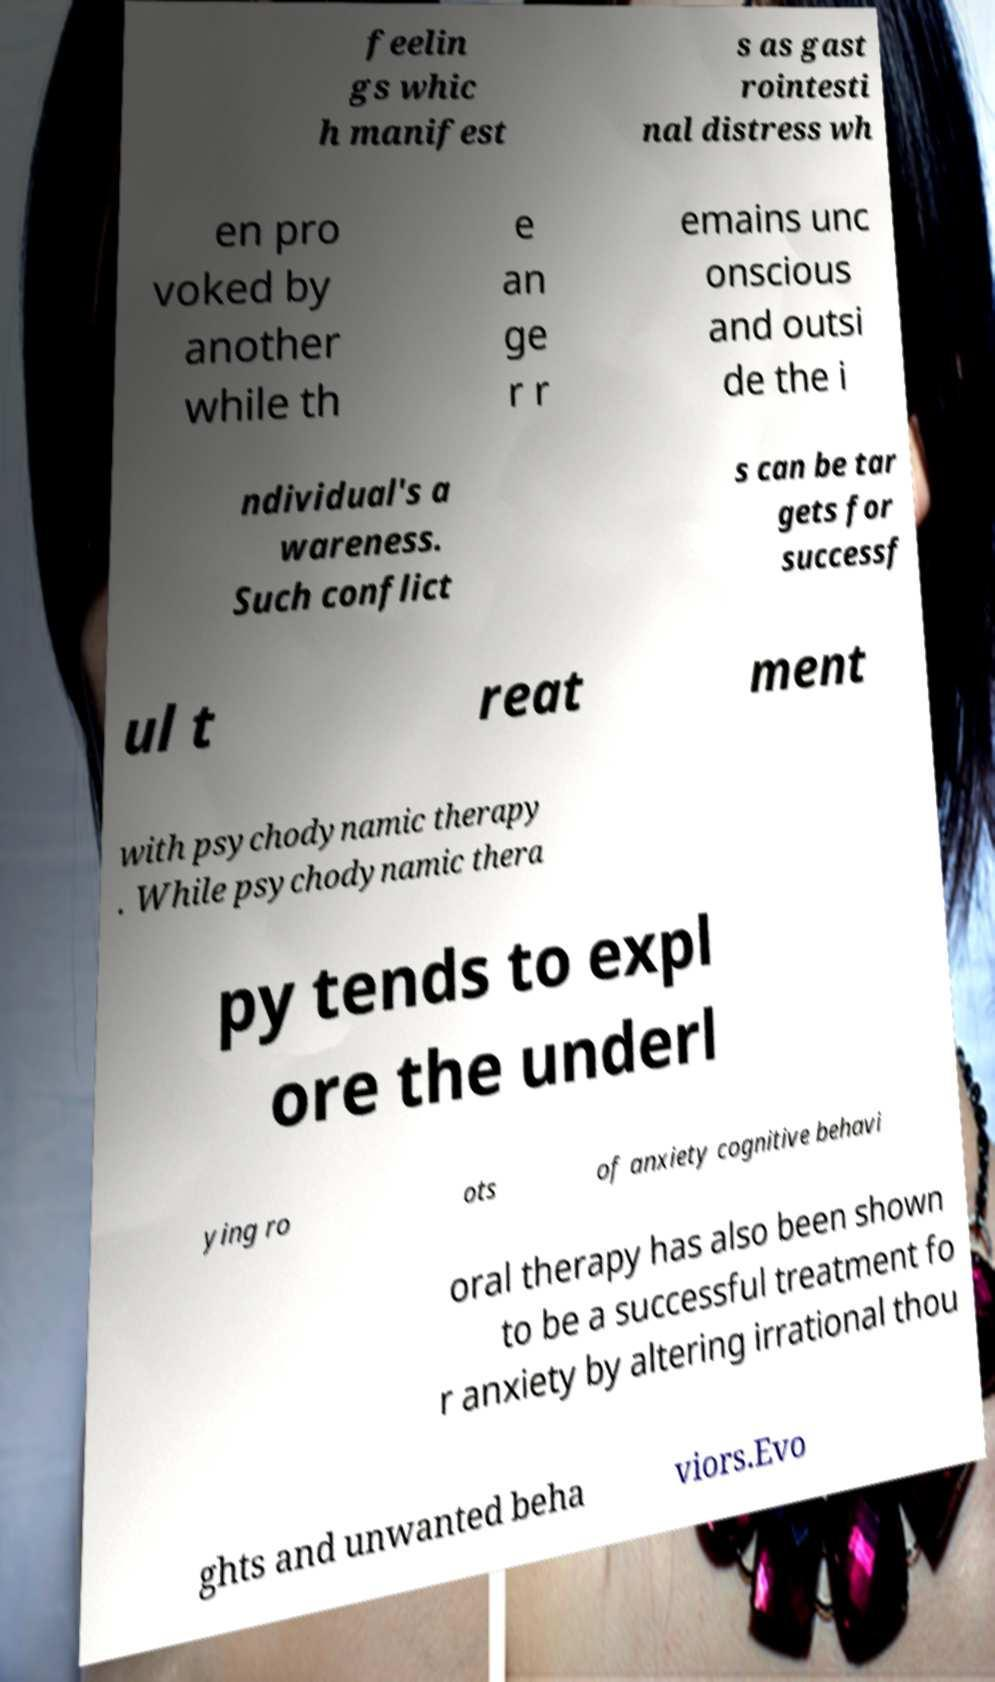I need the written content from this picture converted into text. Can you do that? feelin gs whic h manifest s as gast rointesti nal distress wh en pro voked by another while th e an ge r r emains unc onscious and outsi de the i ndividual's a wareness. Such conflict s can be tar gets for successf ul t reat ment with psychodynamic therapy . While psychodynamic thera py tends to expl ore the underl ying ro ots of anxiety cognitive behavi oral therapy has also been shown to be a successful treatment fo r anxiety by altering irrational thou ghts and unwanted beha viors.Evo 